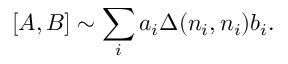<formula> <loc_0><loc_0><loc_500><loc_500>\left [ A , B \right ] \sim \sum _ { i } a _ { i } \Delta ( n _ { i } , n _ { i } ) b _ { i } .</formula> 